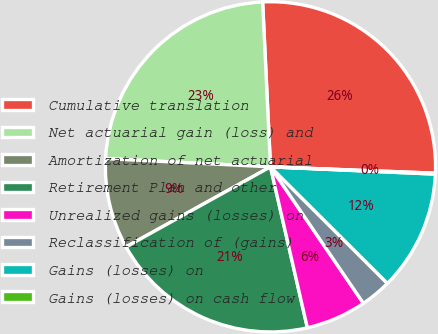<chart> <loc_0><loc_0><loc_500><loc_500><pie_chart><fcel>Cumulative translation<fcel>Net actuarial gain (loss) and<fcel>Amortization of net actuarial<fcel>Retirement Plan and other<fcel>Unrealized gains (losses) on<fcel>Reclassification of (gains)<fcel>Gains (losses) on<fcel>Gains (losses) on cash flow<nl><fcel>26.37%<fcel>23.45%<fcel>8.85%<fcel>20.53%<fcel>5.93%<fcel>3.01%<fcel>11.77%<fcel>0.09%<nl></chart> 